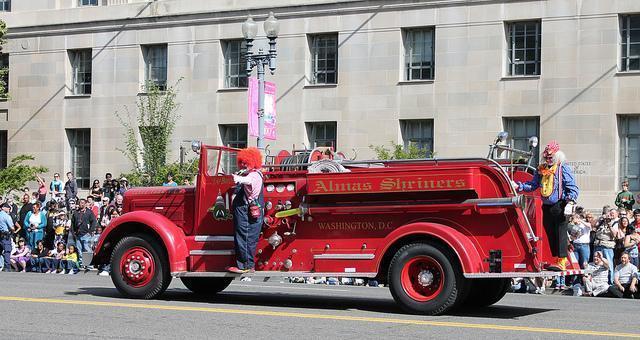How many trucks can you see?
Give a very brief answer. 1. How many people are in the photo?
Give a very brief answer. 3. 